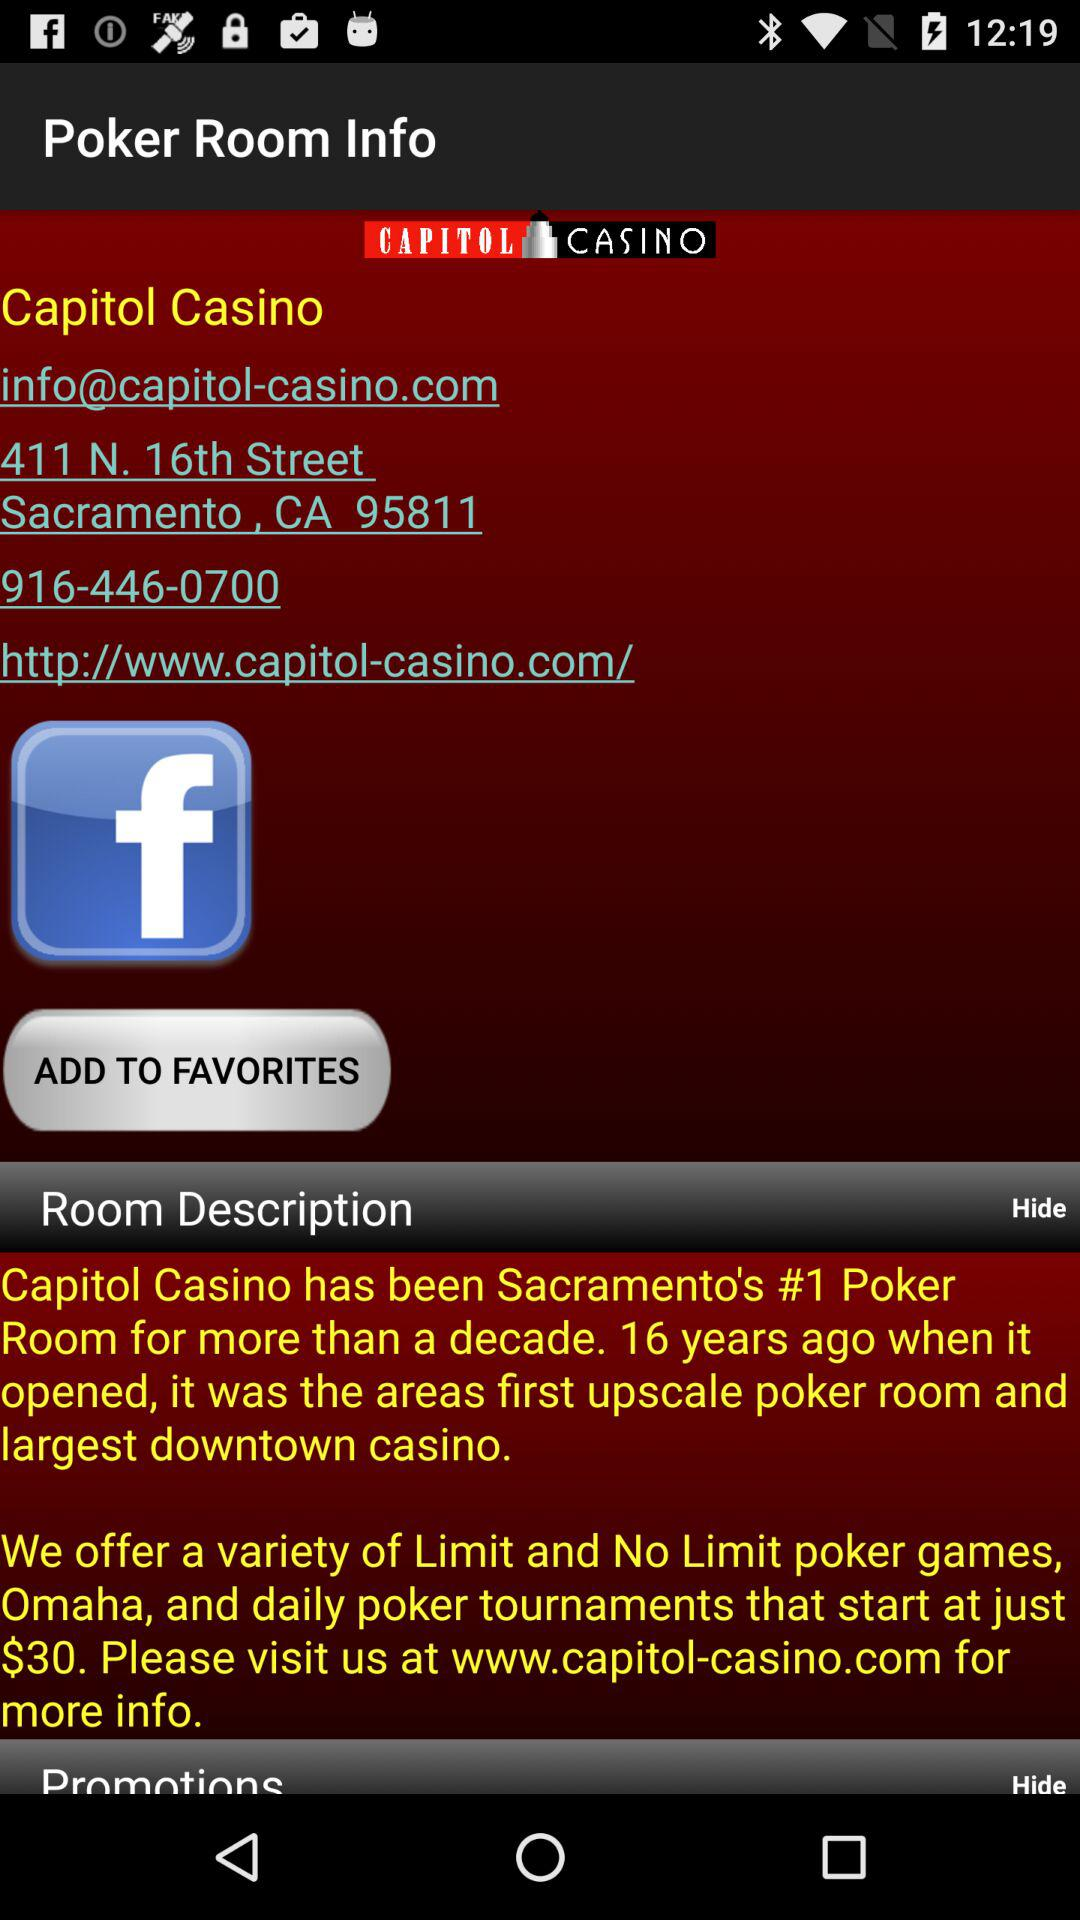What is the web address? The web address is "http://www.capitol-casino.com/". 